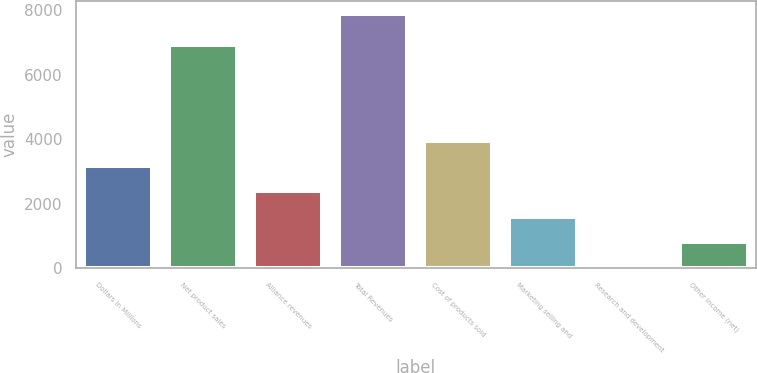Convert chart. <chart><loc_0><loc_0><loc_500><loc_500><bar_chart><fcel>Dollars in Millions<fcel>Net product sales<fcel>Alliance revenues<fcel>Total Revenues<fcel>Cost of products sold<fcel>Marketing selling and<fcel>Research and development<fcel>Other income (net)<nl><fcel>3168.4<fcel>6917<fcel>2383.3<fcel>7879<fcel>3953.5<fcel>1598.2<fcel>28<fcel>813.1<nl></chart> 